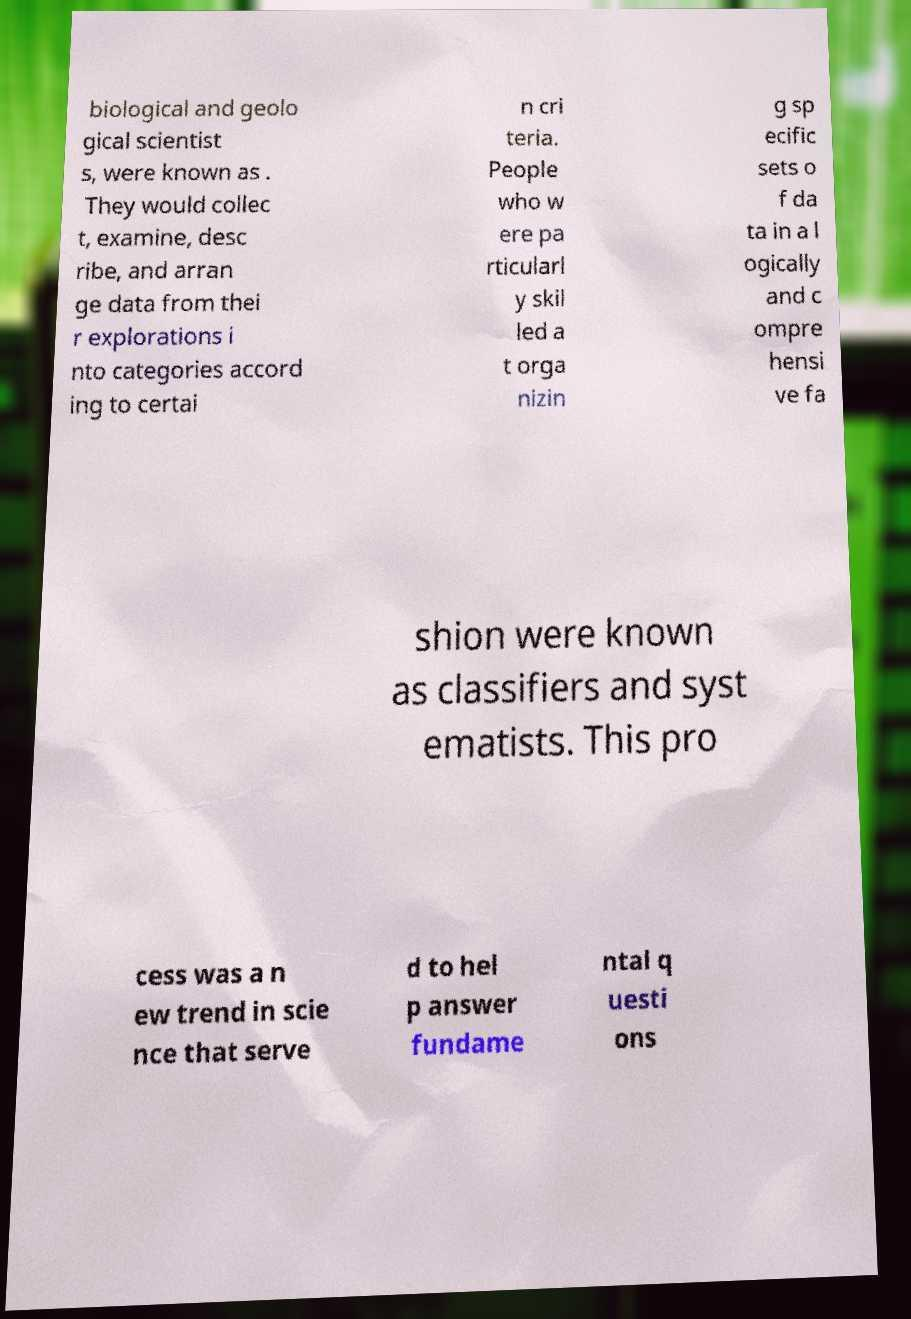Please read and relay the text visible in this image. What does it say? biological and geolo gical scientist s, were known as . They would collec t, examine, desc ribe, and arran ge data from thei r explorations i nto categories accord ing to certai n cri teria. People who w ere pa rticularl y skil led a t orga nizin g sp ecific sets o f da ta in a l ogically and c ompre hensi ve fa shion were known as classifiers and syst ematists. This pro cess was a n ew trend in scie nce that serve d to hel p answer fundame ntal q uesti ons 